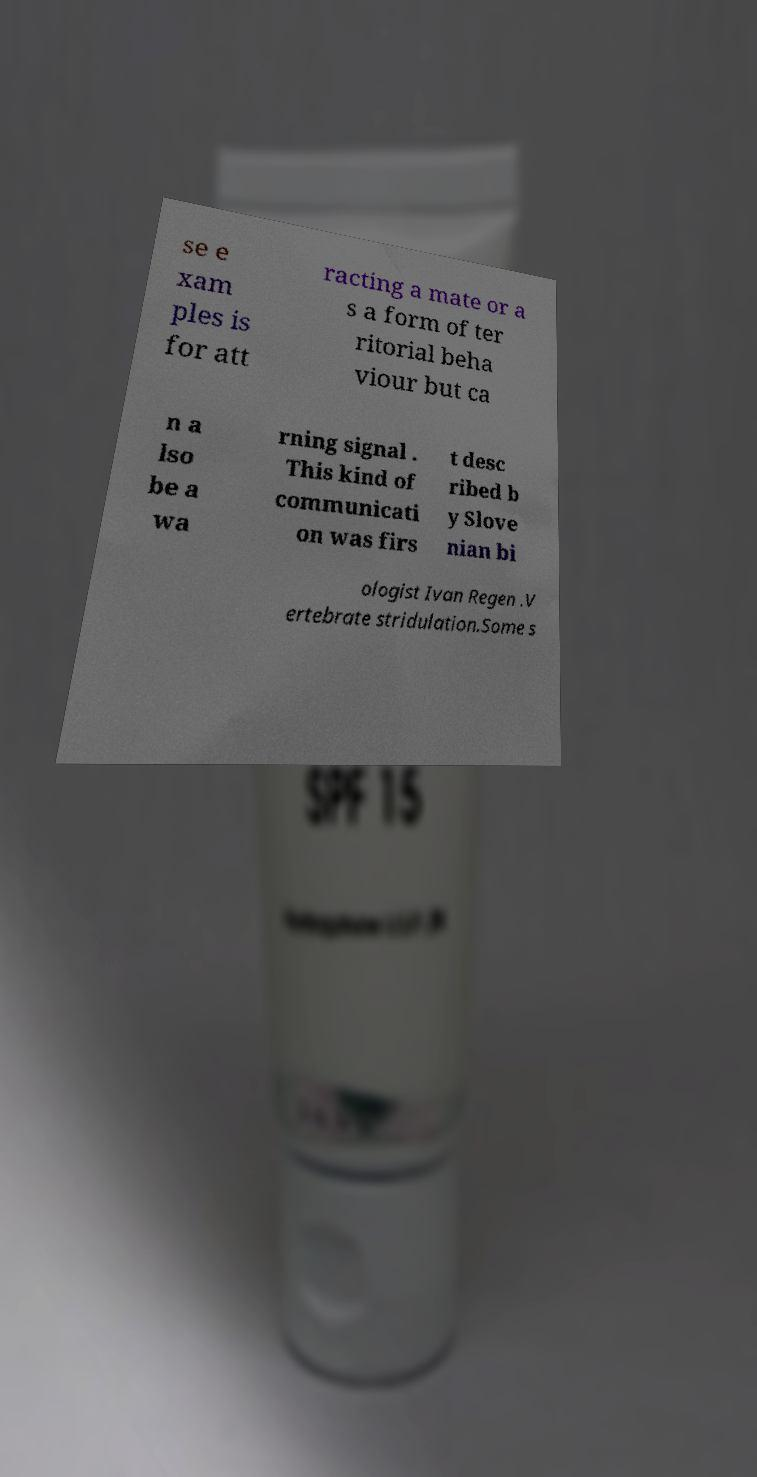Can you accurately transcribe the text from the provided image for me? se e xam ples is for att racting a mate or a s a form of ter ritorial beha viour but ca n a lso be a wa rning signal . This kind of communicati on was firs t desc ribed b y Slove nian bi ologist Ivan Regen .V ertebrate stridulation.Some s 